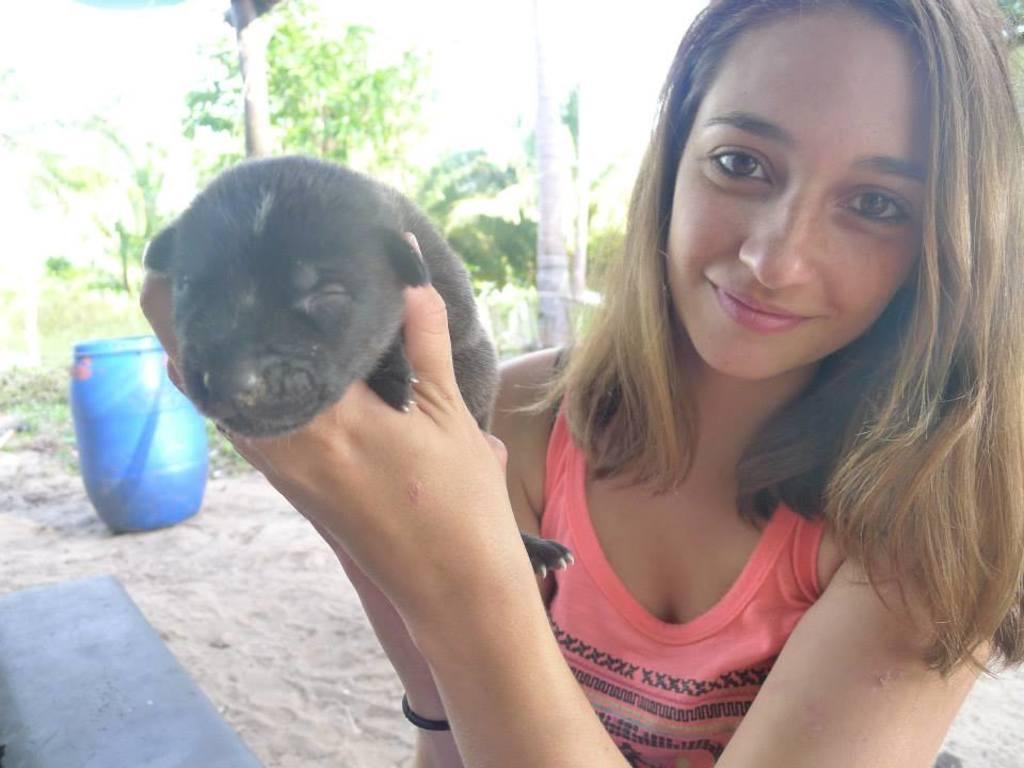How would you summarize this image in a sentence or two? In this image in the center there is one woman who is smiling and and she is holding a puppy. On the background there are some trees and in the bottom there is one drum. 